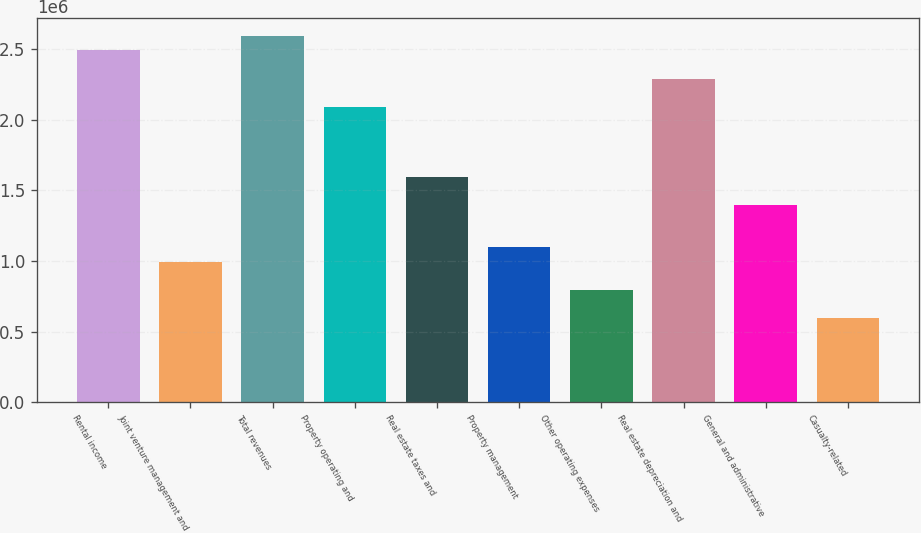Convert chart to OTSL. <chart><loc_0><loc_0><loc_500><loc_500><bar_chart><fcel>Rental income<fcel>Joint venture management and<fcel>Total revenues<fcel>Property operating and<fcel>Real estate taxes and<fcel>Property management<fcel>Other operating expenses<fcel>Real estate depreciation and<fcel>General and administrative<fcel>Casualty-related<nl><fcel>2.48948e+06<fcel>995791<fcel>2.58906e+06<fcel>2.09116e+06<fcel>1.59327e+06<fcel>1.09537e+06<fcel>796633<fcel>2.29032e+06<fcel>1.39411e+06<fcel>597475<nl></chart> 